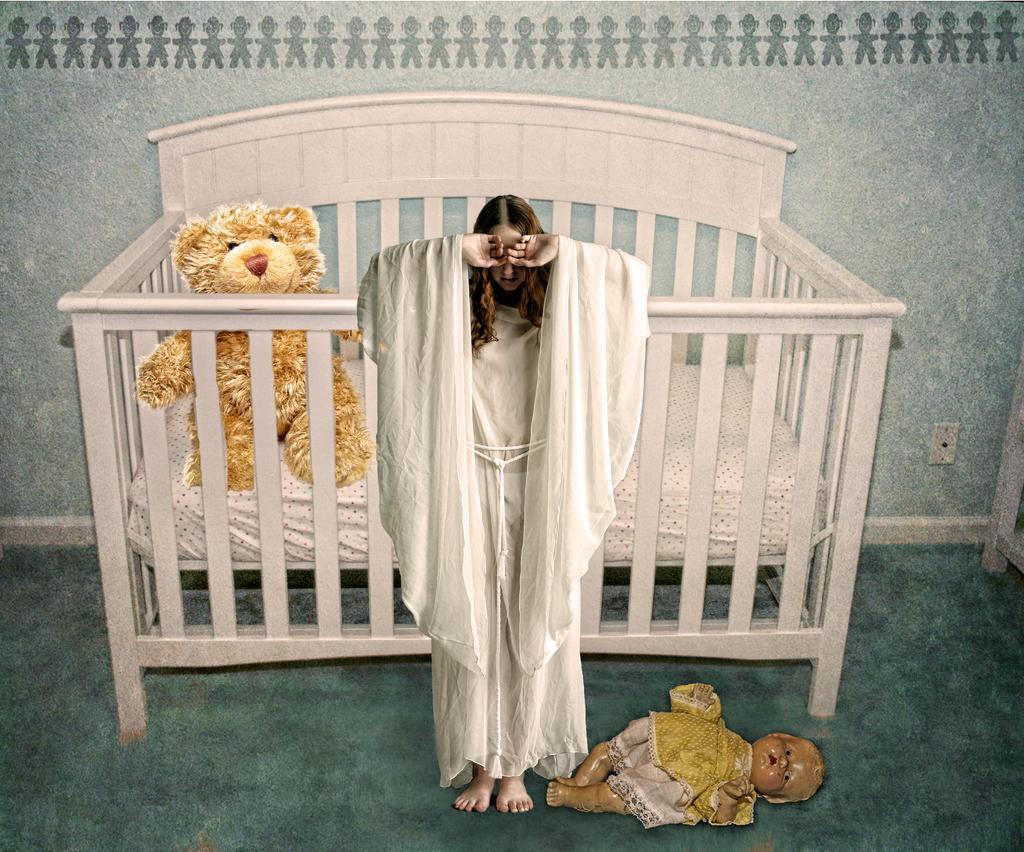Please provide a concise description of this image. In the middle of the image a person is standing. Behind her we can see a cot. In the cot we can see a toy. Behind the cot we can see wall. In the bottom right corner of the image we can see a doll. 